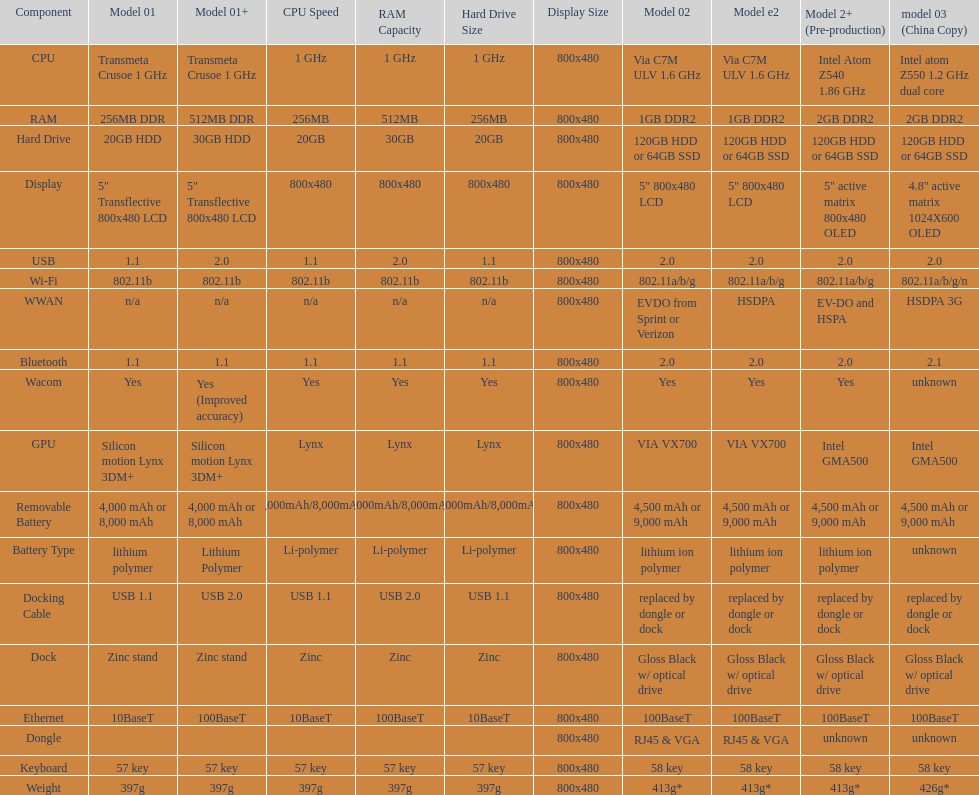Are there at least 13 different components on the chart? Yes. 